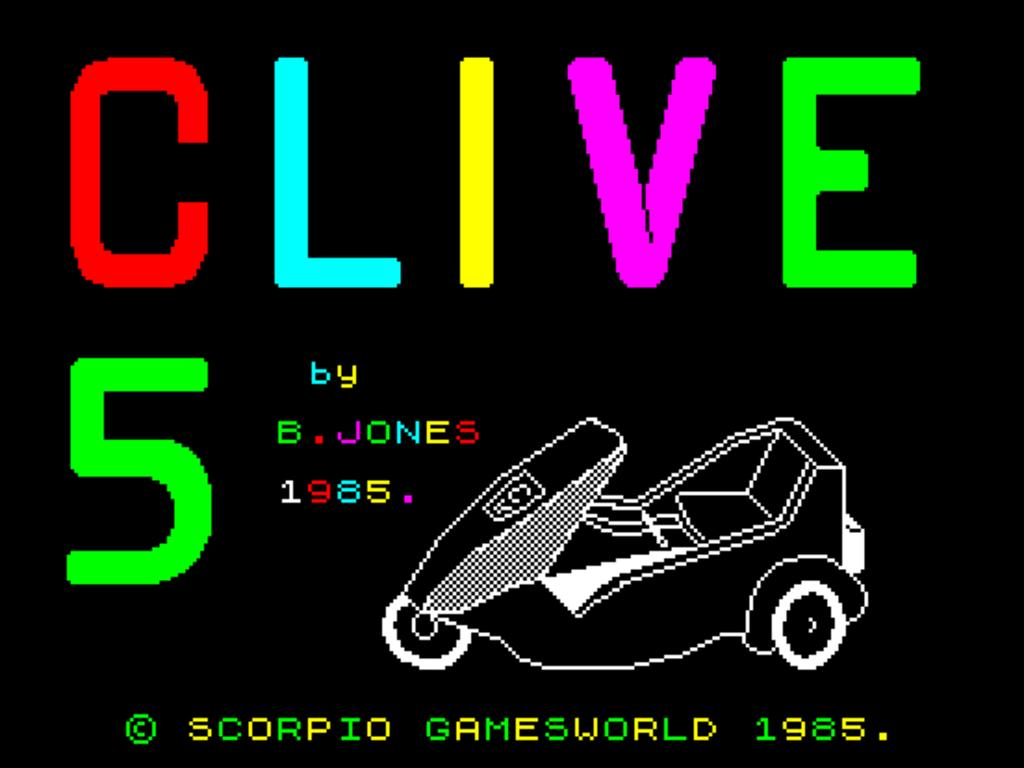What type of object is present in the image that is digital? There is a digital object in the image. What mode of transportation can be seen in the image? There is a vehicle in the image. What type of text is present in the image? There are words in the image. What numerical value is present in the image? There is a number in the image. What color is the background of the image? The background of the image is black. Can you see a mountain in the background of the image? There is no mountain present in the image; the background is black. What type of cork is used to seal the vehicle in the image? There is no cork present in the image, and the vehicle is not sealed. 